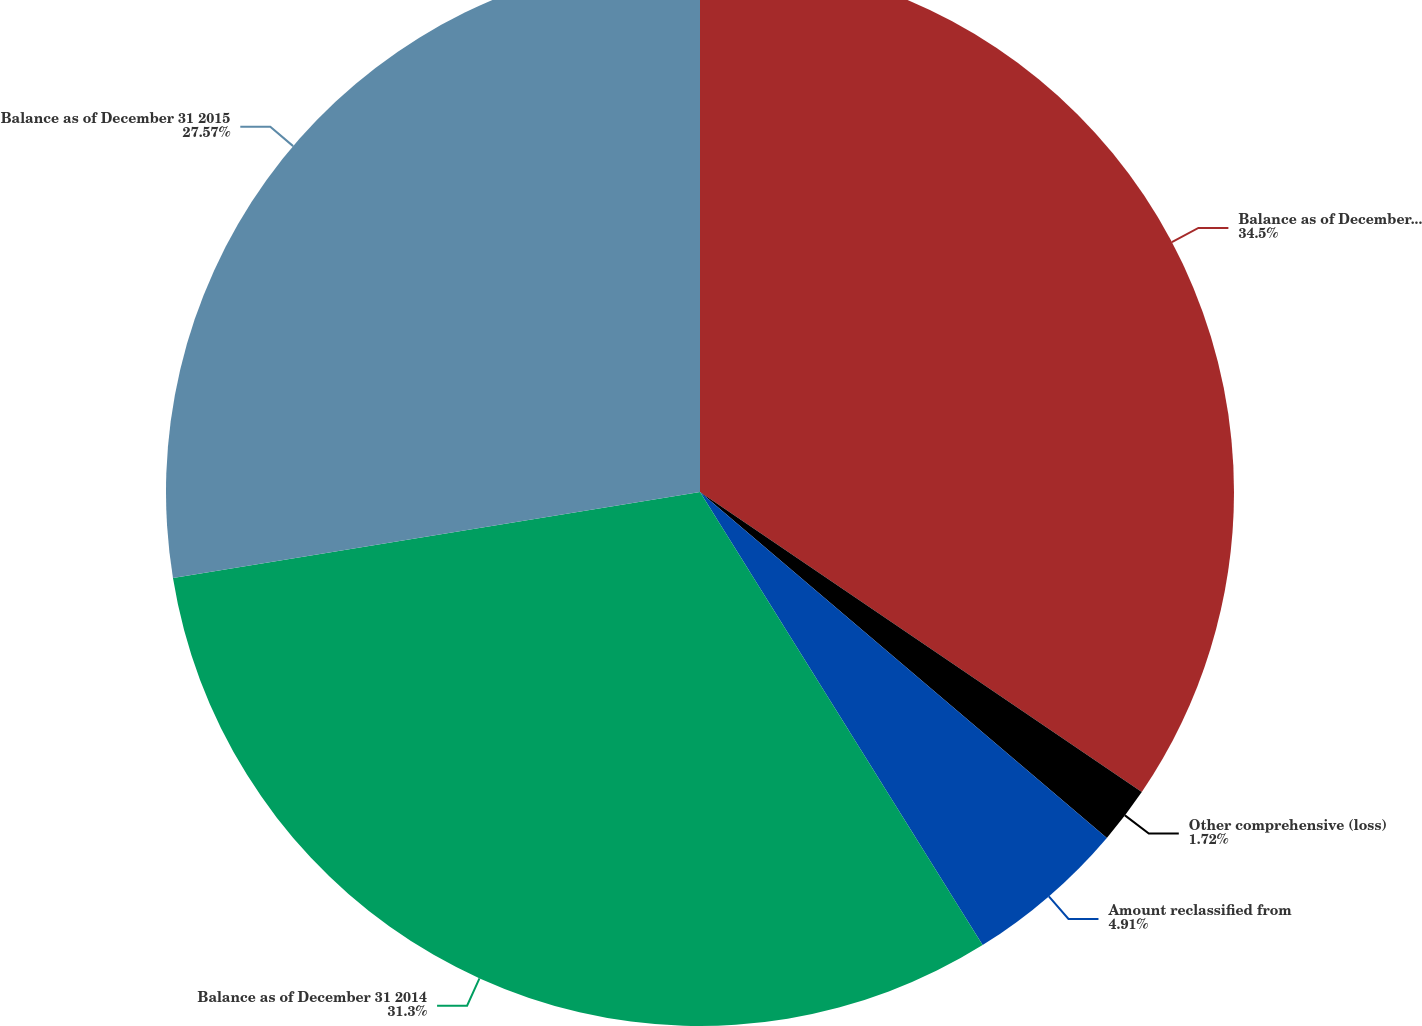<chart> <loc_0><loc_0><loc_500><loc_500><pie_chart><fcel>Balance as of December 31 2013<fcel>Other comprehensive (loss)<fcel>Amount reclassified from<fcel>Balance as of December 31 2014<fcel>Balance as of December 31 2015<nl><fcel>34.49%<fcel>1.72%<fcel>4.91%<fcel>31.3%<fcel>27.57%<nl></chart> 